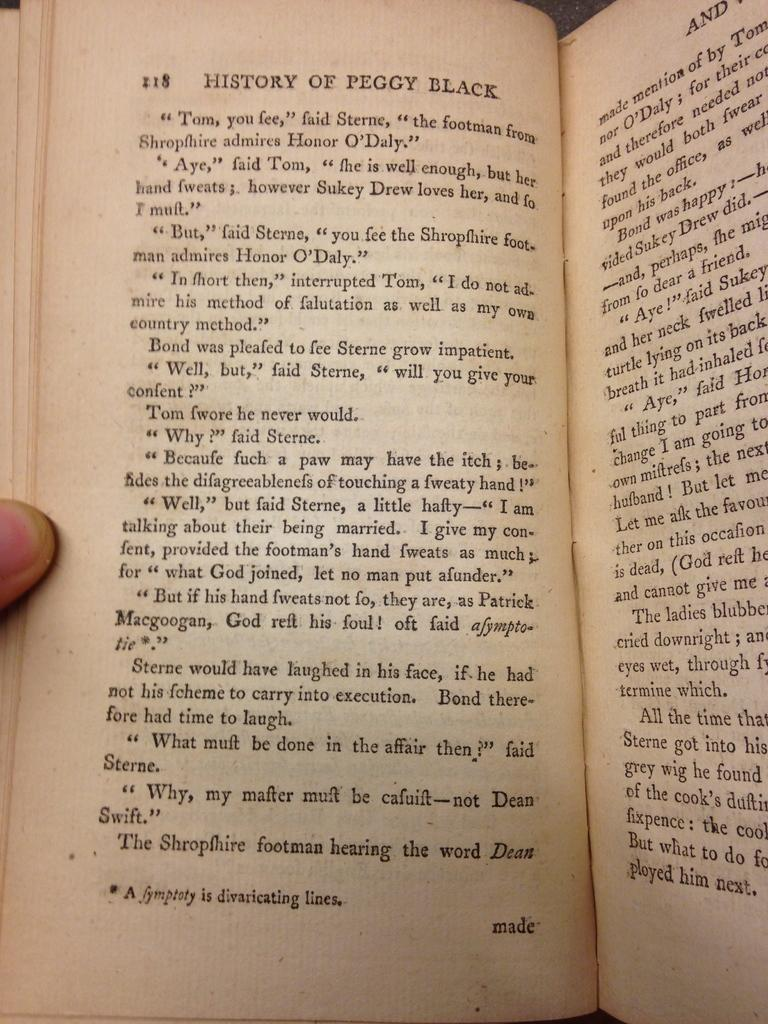<image>
Render a clear and concise summary of the photo. A book called History of Peggy Black opened to page 118. 